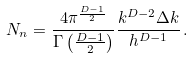<formula> <loc_0><loc_0><loc_500><loc_500>N _ { n } = \frac { 4 \pi ^ { \frac { D - 1 } { 2 } } } { \Gamma \left ( \frac { D - 1 } { 2 } \right ) } \frac { k ^ { D - 2 } \Delta k } { h ^ { D - 1 } } \, .</formula> 